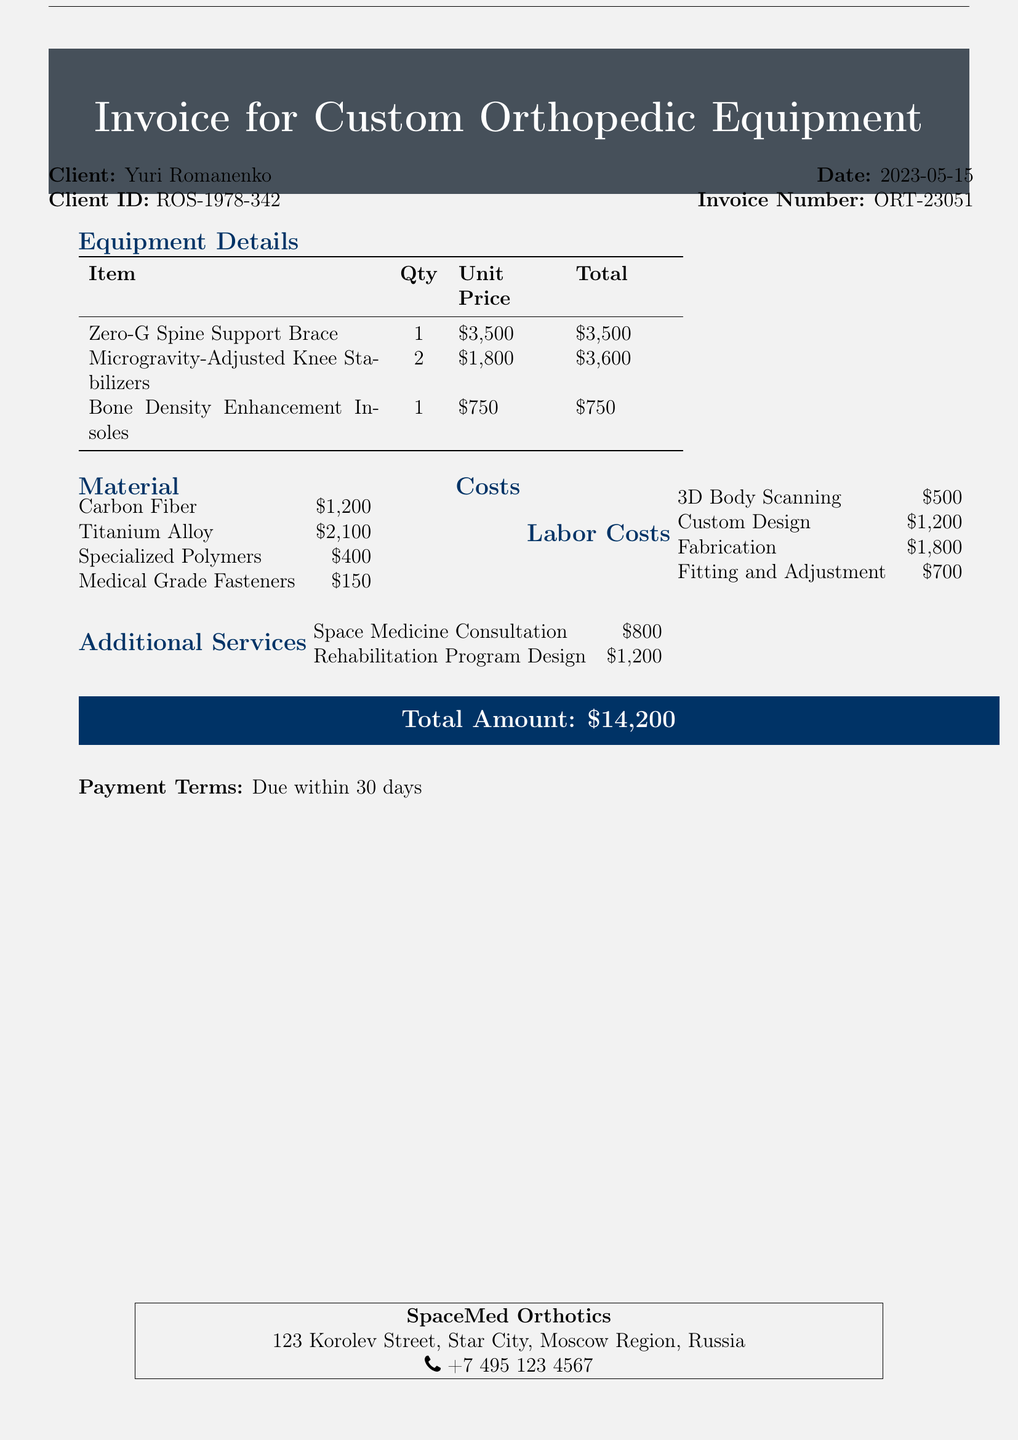what is the invoice number? The invoice number is listed in the document for identification purposes, which is ORT-23051.
Answer: ORT-23051 who is the client? The client's name is provided in the document, which is Yuri Romanenko.
Answer: Yuri Romanenko what is the total amount? The total amount represents the overall cost for the custom orthopedic equipment, which is $14,200.
Answer: $14,200 how many Microgravity-Adjusted Knee Stabilizers are included? The quantity of Microgravity-Adjusted Knee Stabilizers is specified in the equipment details, which is 2.
Answer: 2 what is the cost of space medicine consultation? The cost for space medicine consultation is listed under additional services, which is $800.
Answer: $800 what is the primary material cost incurred for carbon fiber? The document lists the material cost for carbon fiber, which is $1,200.
Answer: $1,200 how much is allocated for 3D body scanning in labor costs? The labor costs include the amount allocated for 3D body scanning, which is $500.
Answer: $500 when is the payment due? The payment terms state that the payment is due within a specific timeline, which is 30 days.
Answer: 30 days what is the total cost of rehabilitation program design? The total cost for rehabilitation program design is specified in the additional services, which is $1,200.
Answer: $1,200 